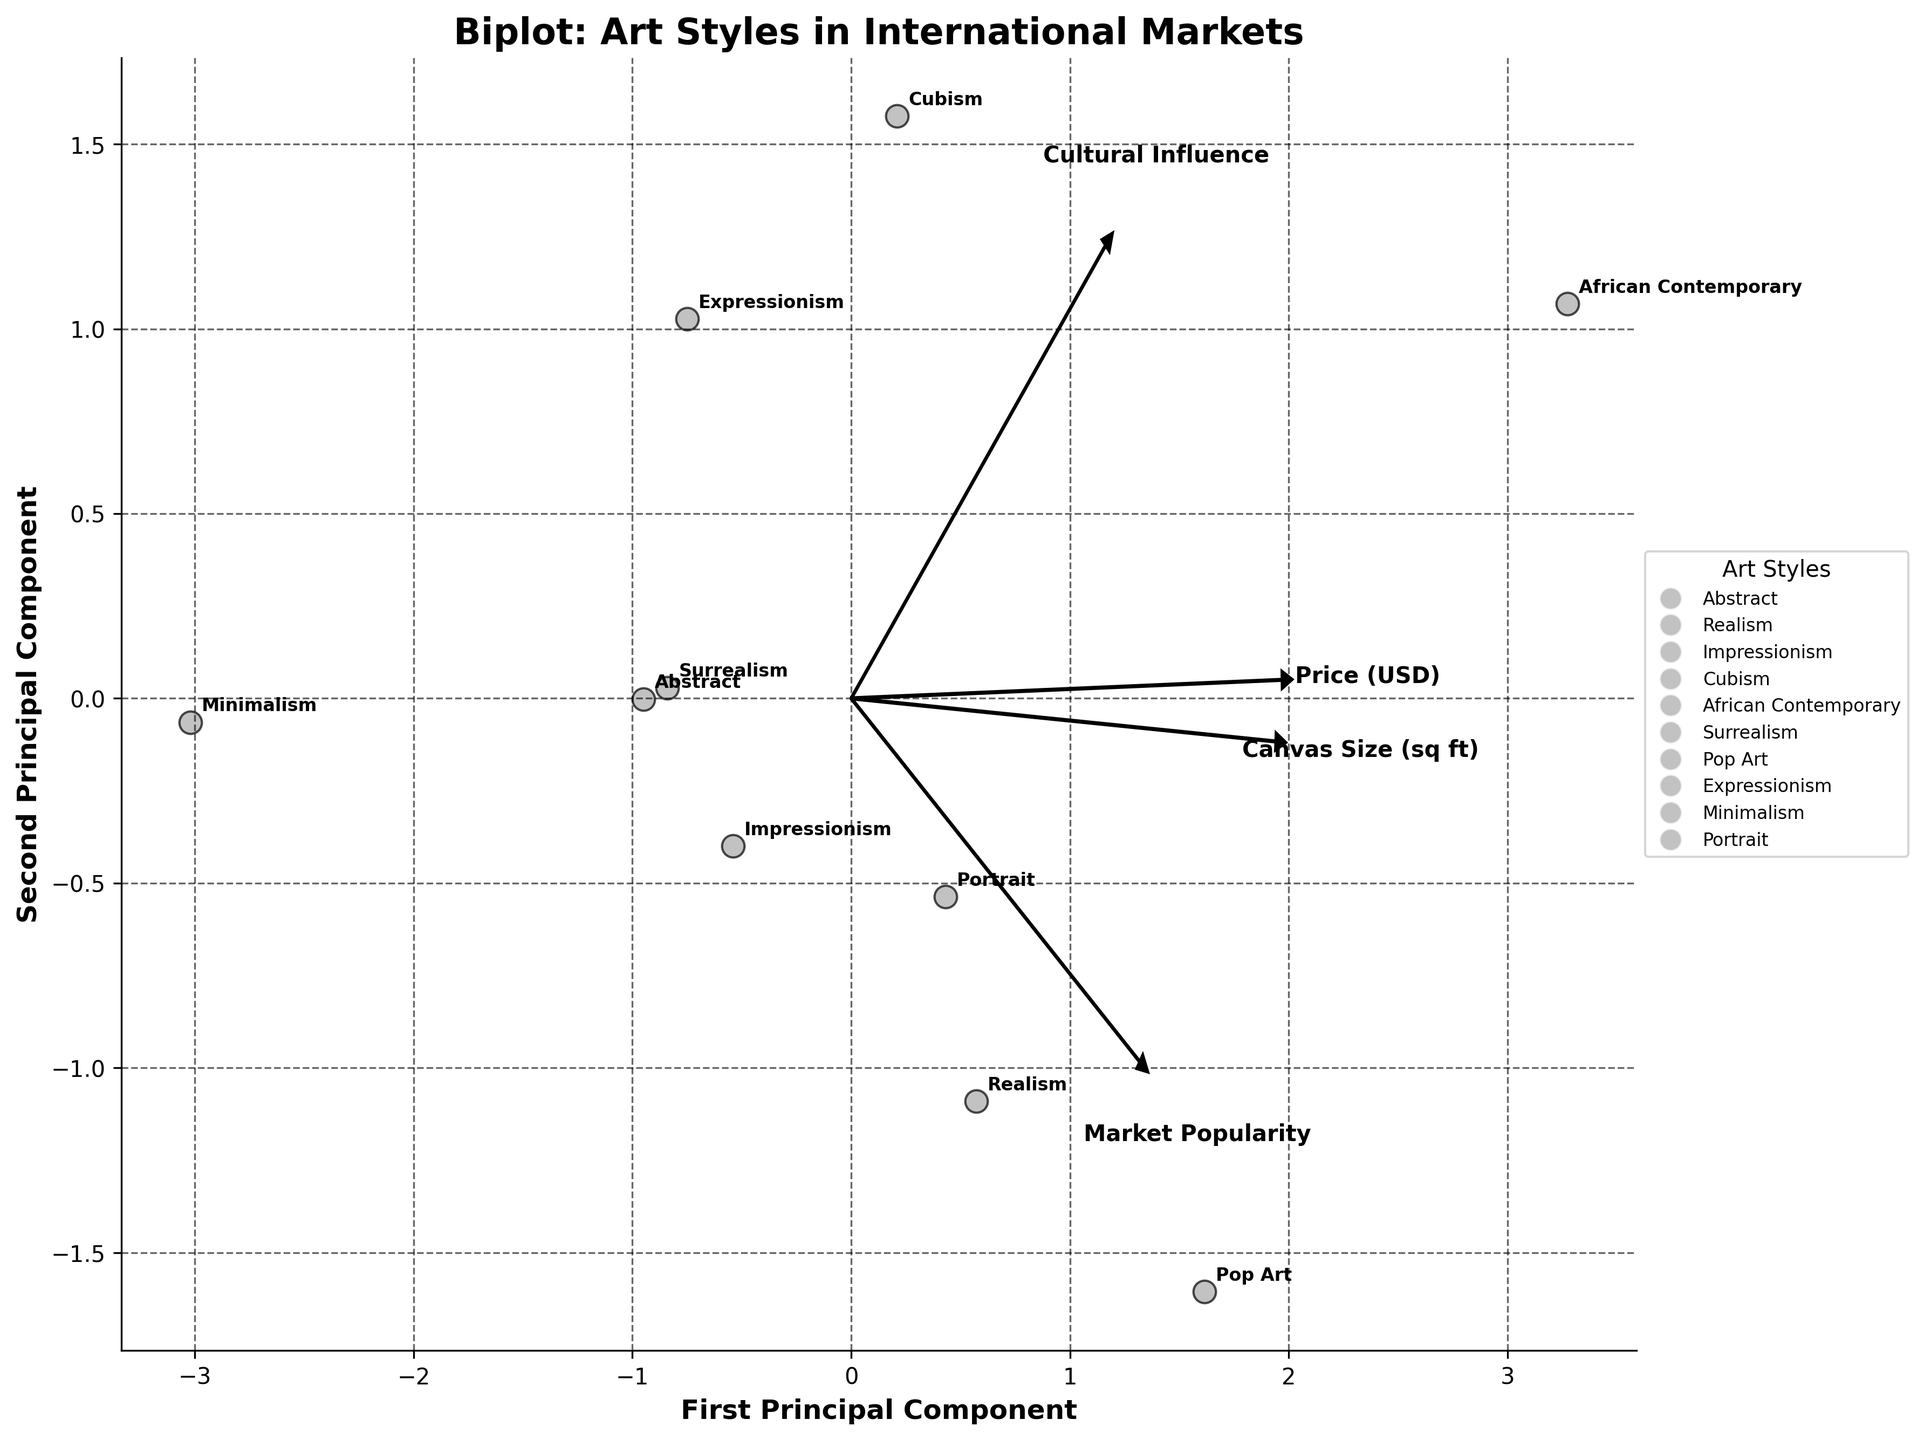What is the title of the biplot? Look at the top of the plot where the title is typically located.
Answer: Biplot: Art Styles in International Markets Which art style has the highest selling price based on the plot? Identify the art style positioned furthest along the direction of the "Price (USD)" vector.
Answer: African Contemporary What are the axes labeled as? Examine the labels next to the axes in the plot.
Answer: First Principal Component, Second Principal Component Which art styles are positioned closest to each other, suggesting similar characteristics? Find the data points that are closest together on the plot.
Answer: Abstract and Surrealism How does market popularity influence the position of art styles on the biplot? Look at the direction and length of the "Market Popularity" vector and note which art styles are aligned with it.
Answer: Art styles with high market popularity are aligned with the vector, like Impressionism and Pop Art Which art style has the largest canvas size in relation to other styles? Find the art style positioned furthest along the "Canvas Size (sq ft)" vector.
Answer: African Contemporary What can be inferred about art styles positioned in the opposite direction of the "Cultural Influence" vector? Identify the data points on the plot that are opposite to the "Cultural Influence" vector direction.
Answer: These art styles, such as Pop Art and Realism, likely have lower cultural influence Which art style is associated with both high price and high cultural influence? Look for the art style closest to the vectors representing "Price (USD)" and "Cultural Influence".
Answer: African Contemporary How are impressionism and cubism related in terms of the given features? Observe their positions and proximity to each vector's direction on the plot.
Answer: Impressionism is closer to market popularity, while cubism has higher cultural influence What art style shows a good balance between the canvas size, price, market popularity, and cultural influence? Look for an art style that is centrally located and not extreme in any specific direction.
Answer: Impressionism 